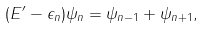<formula> <loc_0><loc_0><loc_500><loc_500>( E ^ { \prime } - \epsilon _ { n } ) \psi _ { n } = \psi _ { n - 1 } + \psi _ { n + 1 } ,</formula> 